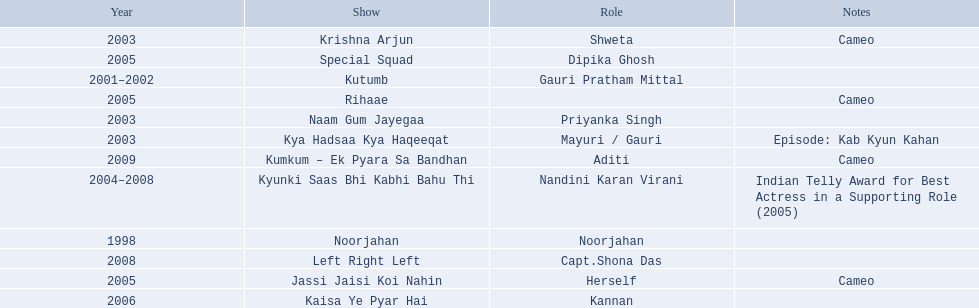On what shows did gauri pradhan tejwani appear after 2000? Kutumb, Krishna Arjun, Naam Gum Jayegaa, Kya Hadsaa Kya Haqeeqat, Kyunki Saas Bhi Kabhi Bahu Thi, Rihaae, Jassi Jaisi Koi Nahin, Special Squad, Kaisa Ye Pyar Hai, Left Right Left, Kumkum – Ek Pyara Sa Bandhan. In which of them was is a cameo appearance? Krishna Arjun, Rihaae, Jassi Jaisi Koi Nahin, Kumkum – Ek Pyara Sa Bandhan. Of these which one did she play the role of herself? Jassi Jaisi Koi Nahin. Could you help me parse every detail presented in this table? {'header': ['Year', 'Show', 'Role', 'Notes'], 'rows': [['2003', 'Krishna Arjun', 'Shweta', 'Cameo'], ['2005', 'Special Squad', 'Dipika Ghosh', ''], ['2001–2002', 'Kutumb', 'Gauri Pratham Mittal', ''], ['2005', 'Rihaae', '', 'Cameo'], ['2003', 'Naam Gum Jayegaa', 'Priyanka Singh', ''], ['2003', 'Kya Hadsaa Kya Haqeeqat', 'Mayuri / Gauri', 'Episode: Kab Kyun Kahan'], ['2009', 'Kumkum – Ek Pyara Sa Bandhan', 'Aditi', 'Cameo'], ['2004–2008', 'Kyunki Saas Bhi Kabhi Bahu Thi', 'Nandini Karan Virani', 'Indian Telly Award for Best Actress in a Supporting Role (2005)'], ['1998', 'Noorjahan', 'Noorjahan', ''], ['2008', 'Left Right Left', 'Capt.Shona Das', ''], ['2005', 'Jassi Jaisi Koi Nahin', 'Herself', 'Cameo'], ['2006', 'Kaisa Ye Pyar Hai', 'Kannan', '']]} 